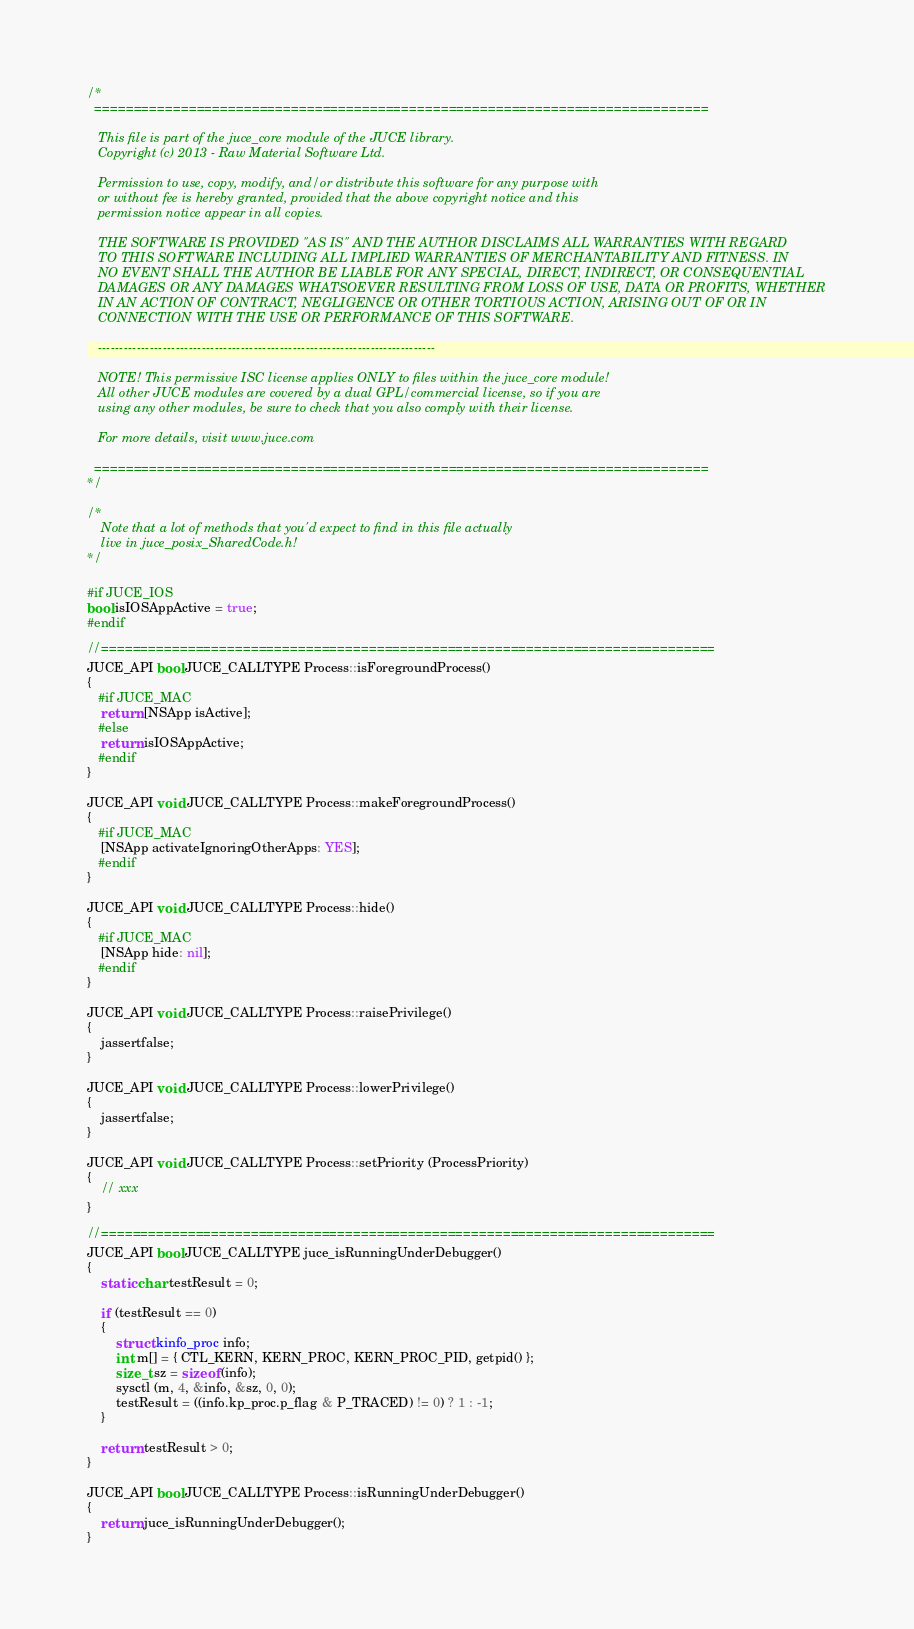<code> <loc_0><loc_0><loc_500><loc_500><_ObjectiveC_>/*
  ==============================================================================

   This file is part of the juce_core module of the JUCE library.
   Copyright (c) 2013 - Raw Material Software Ltd.

   Permission to use, copy, modify, and/or distribute this software for any purpose with
   or without fee is hereby granted, provided that the above copyright notice and this
   permission notice appear in all copies.

   THE SOFTWARE IS PROVIDED "AS IS" AND THE AUTHOR DISCLAIMS ALL WARRANTIES WITH REGARD
   TO THIS SOFTWARE INCLUDING ALL IMPLIED WARRANTIES OF MERCHANTABILITY AND FITNESS. IN
   NO EVENT SHALL THE AUTHOR BE LIABLE FOR ANY SPECIAL, DIRECT, INDIRECT, OR CONSEQUENTIAL
   DAMAGES OR ANY DAMAGES WHATSOEVER RESULTING FROM LOSS OF USE, DATA OR PROFITS, WHETHER
   IN AN ACTION OF CONTRACT, NEGLIGENCE OR OTHER TORTIOUS ACTION, ARISING OUT OF OR IN
   CONNECTION WITH THE USE OR PERFORMANCE OF THIS SOFTWARE.

   ------------------------------------------------------------------------------

   NOTE! This permissive ISC license applies ONLY to files within the juce_core module!
   All other JUCE modules are covered by a dual GPL/commercial license, so if you are
   using any other modules, be sure to check that you also comply with their license.

   For more details, visit www.juce.com

  ==============================================================================
*/

/*
    Note that a lot of methods that you'd expect to find in this file actually
    live in juce_posix_SharedCode.h!
*/

#if JUCE_IOS
bool isIOSAppActive = true;
#endif

//==============================================================================
JUCE_API bool JUCE_CALLTYPE Process::isForegroundProcess()
{
   #if JUCE_MAC
    return [NSApp isActive];
   #else
    return isIOSAppActive;
   #endif
}

JUCE_API void JUCE_CALLTYPE Process::makeForegroundProcess()
{
   #if JUCE_MAC
    [NSApp activateIgnoringOtherApps: YES];
   #endif
}

JUCE_API void JUCE_CALLTYPE Process::hide()
{
   #if JUCE_MAC
    [NSApp hide: nil];
   #endif
}

JUCE_API void JUCE_CALLTYPE Process::raisePrivilege()
{
    jassertfalse;
}

JUCE_API void JUCE_CALLTYPE Process::lowerPrivilege()
{
    jassertfalse;
}

JUCE_API void JUCE_CALLTYPE Process::setPriority (ProcessPriority)
{
    // xxx
}

//==============================================================================
JUCE_API bool JUCE_CALLTYPE juce_isRunningUnderDebugger()
{
    static char testResult = 0;

    if (testResult == 0)
    {
        struct kinfo_proc info;
        int m[] = { CTL_KERN, KERN_PROC, KERN_PROC_PID, getpid() };
        size_t sz = sizeof (info);
        sysctl (m, 4, &info, &sz, 0, 0);
        testResult = ((info.kp_proc.p_flag & P_TRACED) != 0) ? 1 : -1;
    }

    return testResult > 0;
}

JUCE_API bool JUCE_CALLTYPE Process::isRunningUnderDebugger()
{
    return juce_isRunningUnderDebugger();
}
</code> 